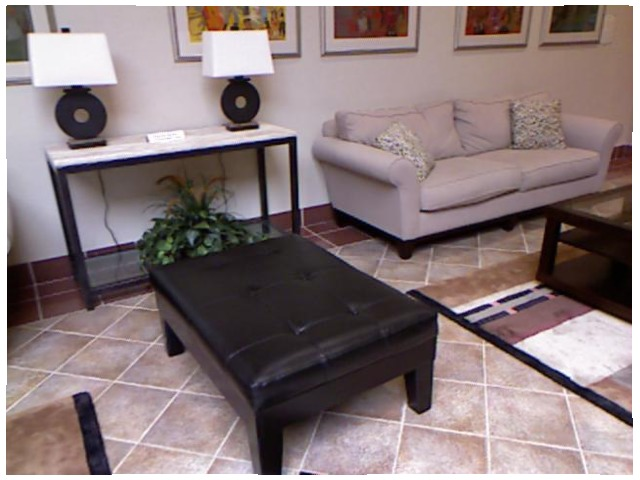<image>
Is there a floor under the table? Yes. The floor is positioned underneath the table, with the table above it in the vertical space. Is there a sofa on the pillow? No. The sofa is not positioned on the pillow. They may be near each other, but the sofa is not supported by or resting on top of the pillow. Is there a rug to the right of the frame? Yes. From this viewpoint, the rug is positioned to the right side relative to the frame. 